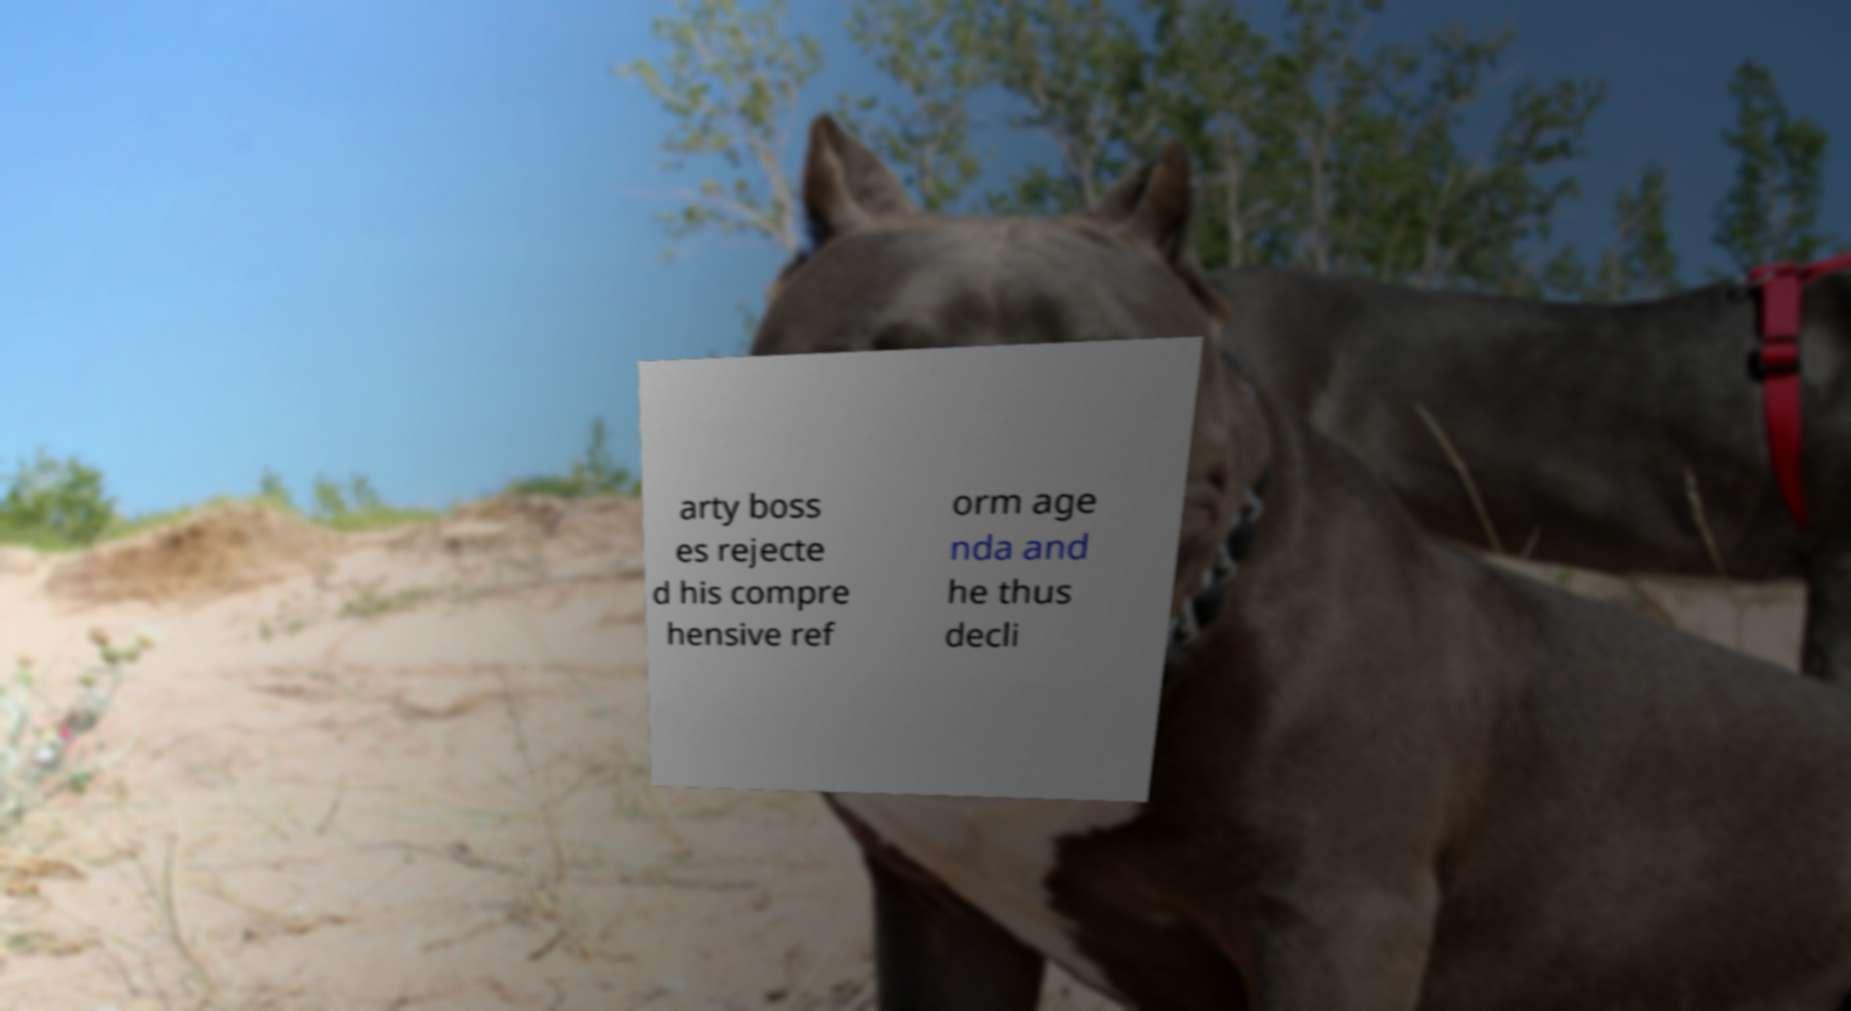For documentation purposes, I need the text within this image transcribed. Could you provide that? arty boss es rejecte d his compre hensive ref orm age nda and he thus decli 